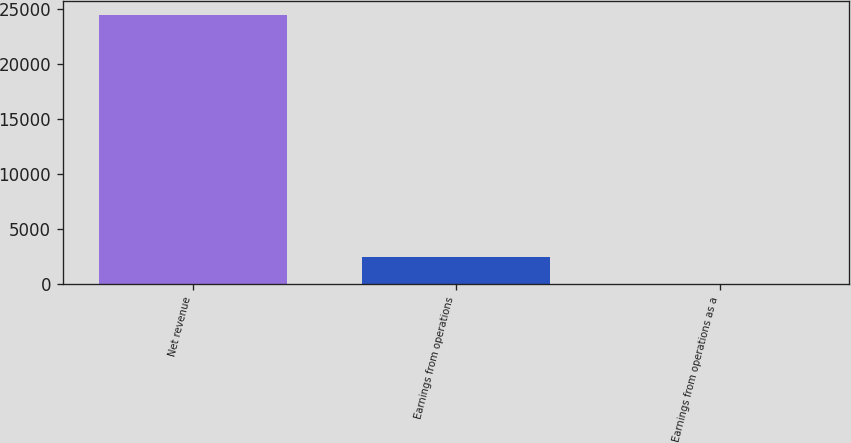Convert chart to OTSL. <chart><loc_0><loc_0><loc_500><loc_500><bar_chart><fcel>Net revenue<fcel>Earnings from operations<fcel>Earnings from operations as a<nl><fcel>24498<fcel>2503<fcel>10.2<nl></chart> 